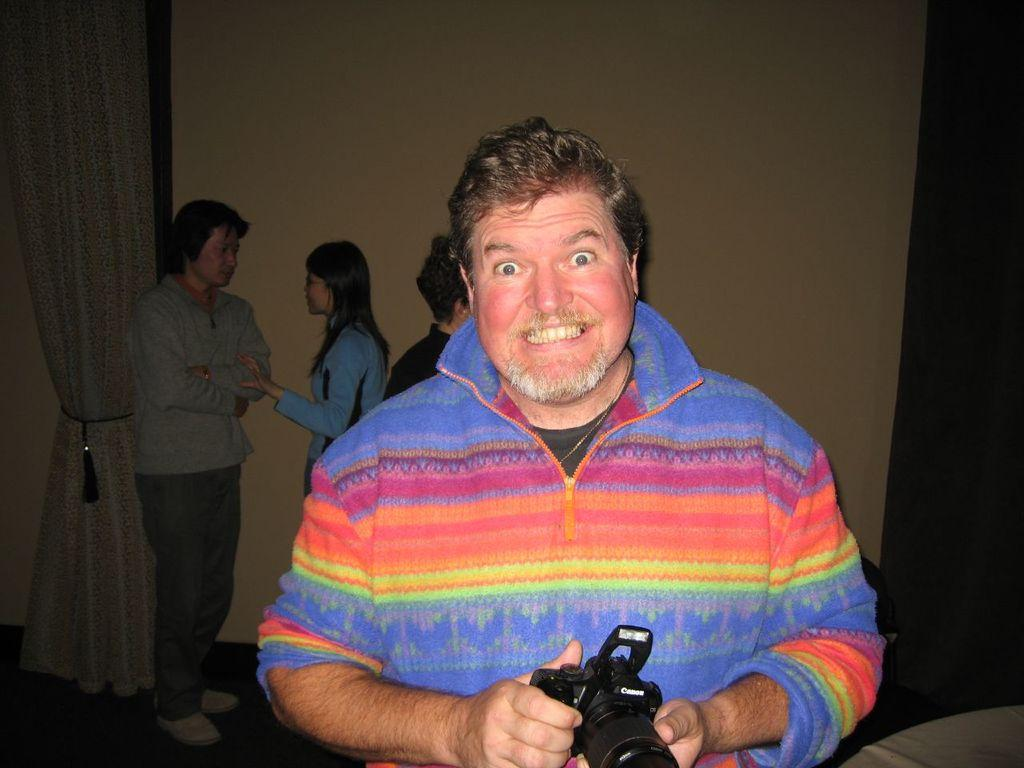What is present in the image that can be used for covering or separating spaces? There is a curtain in the image. What type of structure can be seen in the background of the image? There is a wall in the image. How many people are present in the image? There are four people in the image. Can you describe the man standing in the front? The man standing in the front is a man, and he is holding a camera in his hands. What type of brush is being used to sort the day in the image? There is no brush or sorting activity involving a day present in the image. 